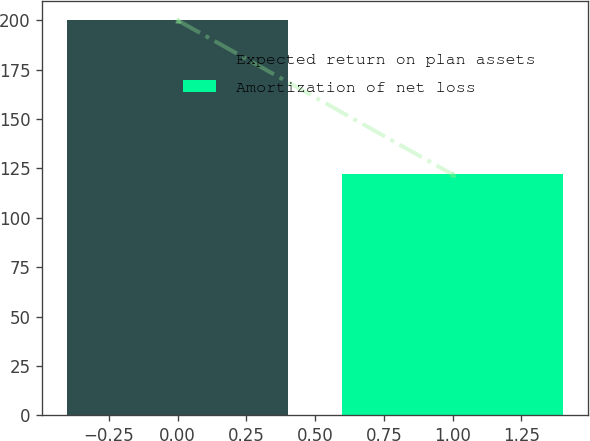Convert chart. <chart><loc_0><loc_0><loc_500><loc_500><bar_chart><fcel>Expected return on plan assets<fcel>Amortization of net loss<nl><fcel>200<fcel>122<nl></chart> 